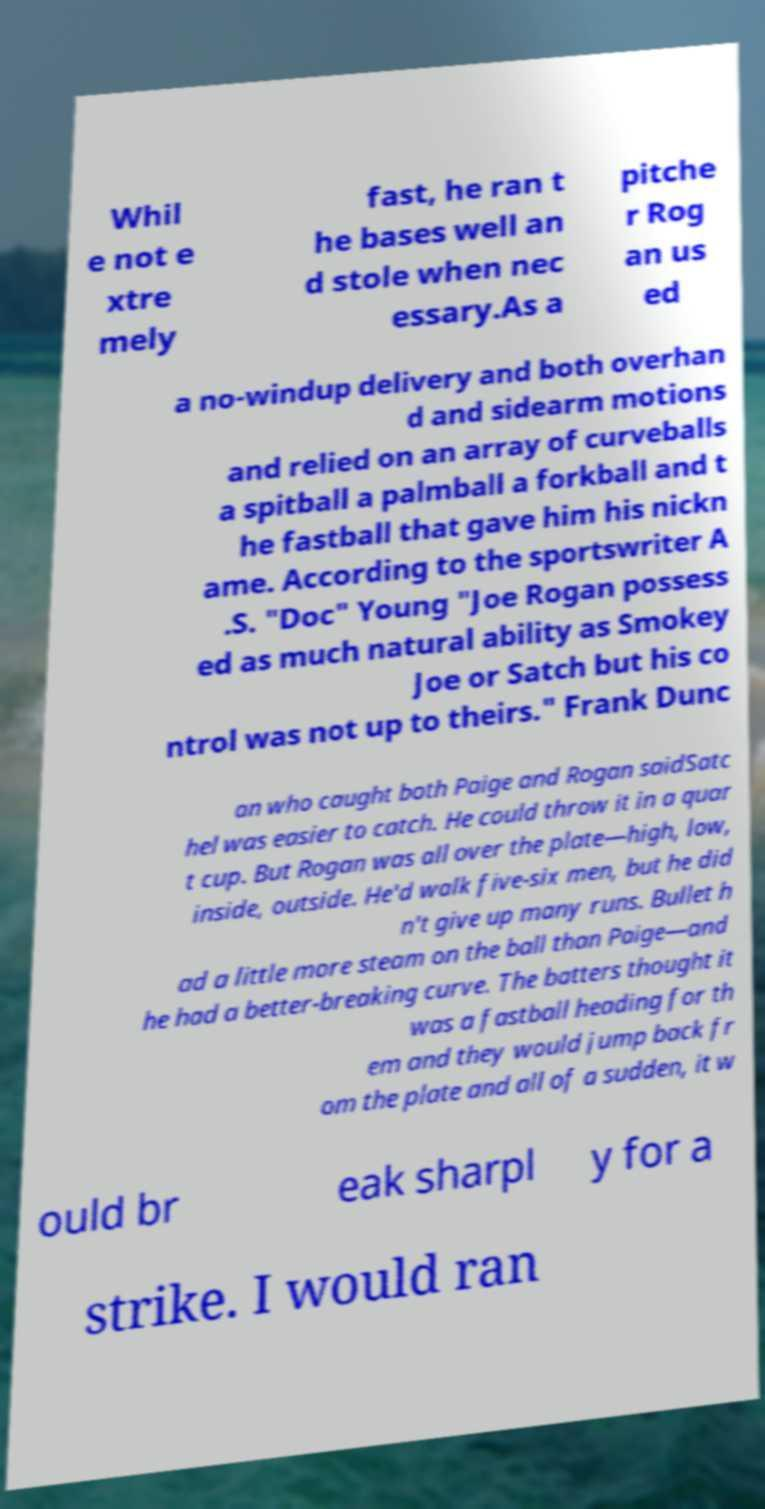What messages or text are displayed in this image? I need them in a readable, typed format. Whil e not e xtre mely fast, he ran t he bases well an d stole when nec essary.As a pitche r Rog an us ed a no-windup delivery and both overhan d and sidearm motions and relied on an array of curveballs a spitball a palmball a forkball and t he fastball that gave him his nickn ame. According to the sportswriter A .S. "Doc" Young "Joe Rogan possess ed as much natural ability as Smokey Joe or Satch but his co ntrol was not up to theirs." Frank Dunc an who caught both Paige and Rogan saidSatc hel was easier to catch. He could throw it in a quar t cup. But Rogan was all over the plate—high, low, inside, outside. He'd walk five-six men, but he did n't give up many runs. Bullet h ad a little more steam on the ball than Paige—and he had a better-breaking curve. The batters thought it was a fastball heading for th em and they would jump back fr om the plate and all of a sudden, it w ould br eak sharpl y for a strike. I would ran 